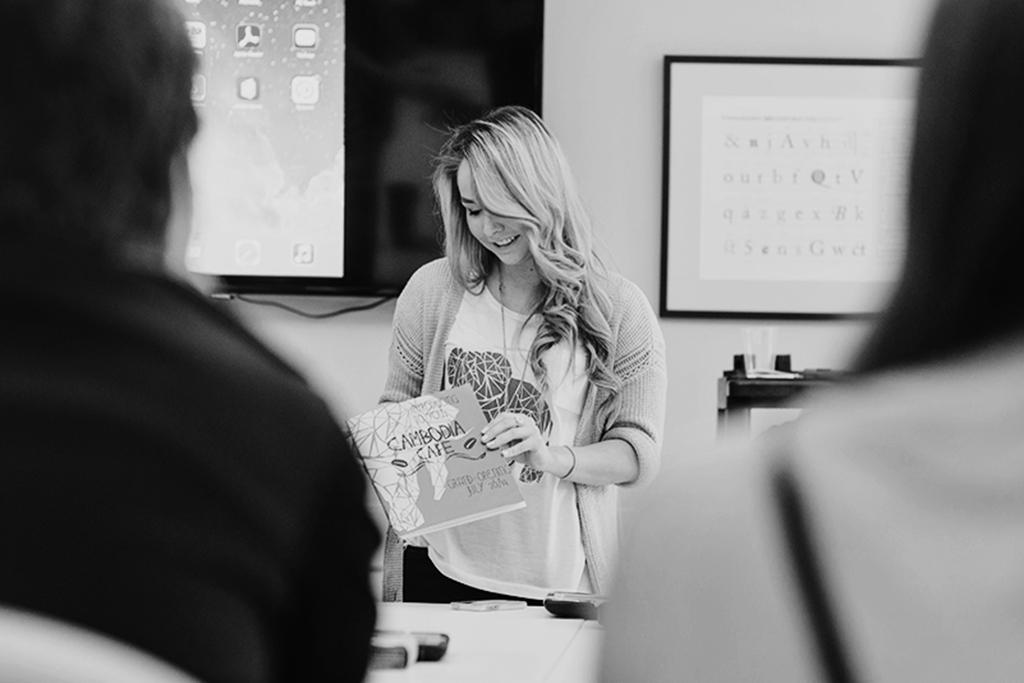What is the main subject of the picture? The main subject of the picture is a woman. What is the woman doing in the picture? The woman is standing in the picture. What is the woman holding in her hands? The woman is holding a book in her hands. How many people are in front of the woman? There are two persons in front of the woman. What can be seen in the background of the picture? There are two projected images in the background. What type of shade is covering the woman's toes in the image? There is no shade covering the woman's toes in the image, as she is standing and her feet are not visible. What town is depicted in the projected images in the background? The provided facts do not mention any specific town or location depicted in the projected images. 